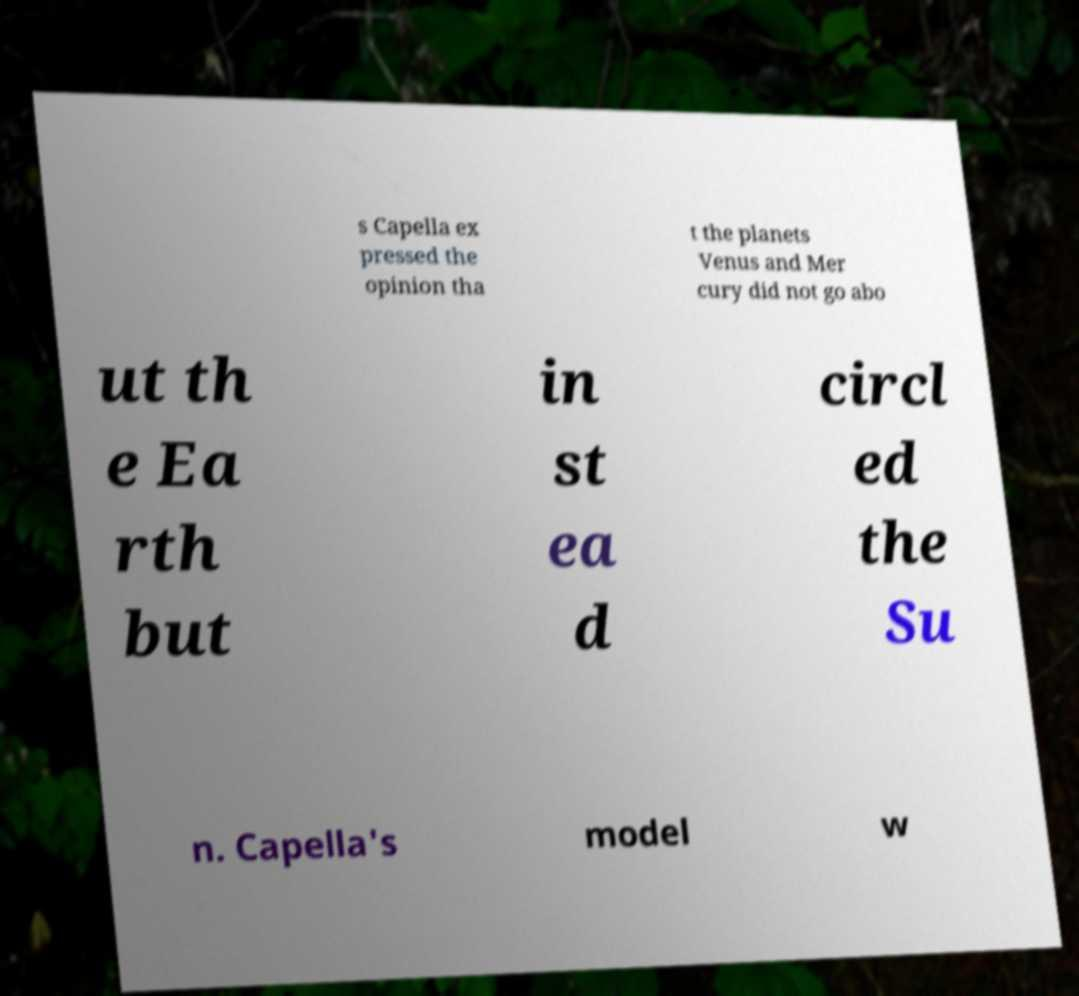Please identify and transcribe the text found in this image. s Capella ex pressed the opinion tha t the planets Venus and Mer cury did not go abo ut th e Ea rth but in st ea d circl ed the Su n. Capella's model w 